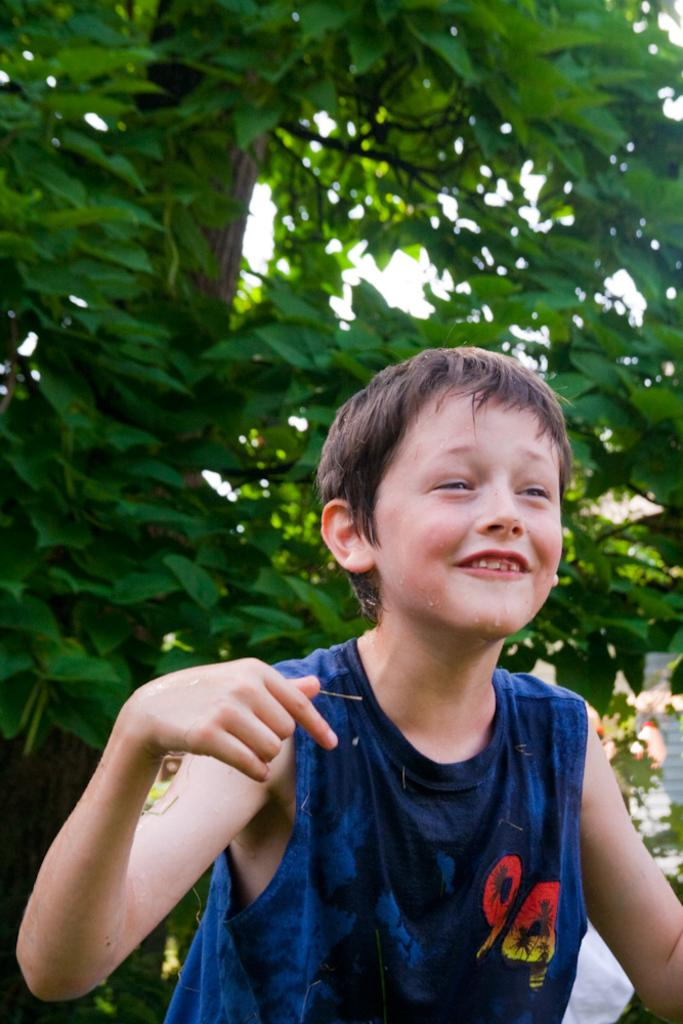Where was the image taken? The image is taken outdoors. What can be seen in the background of the image? There is a tree with leaves, stems, and branches in the background. What is the main subject of the image? There is a kid in the middle of the image. How many pies are on the ground in the image? There are no pies present in the image. 